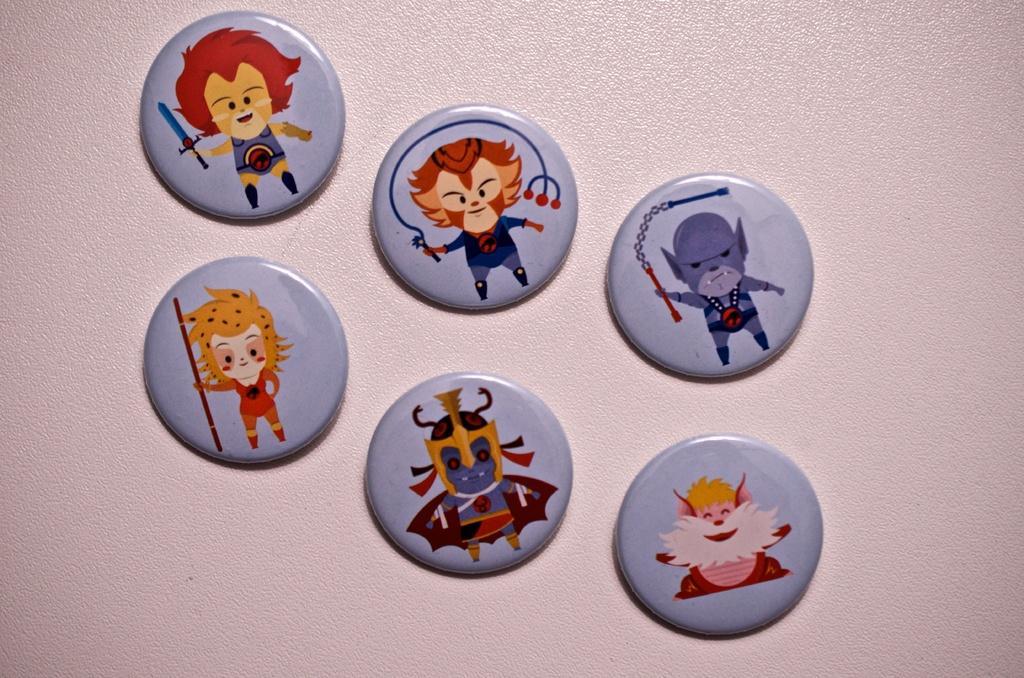How would you summarize this image in a sentence or two? In this image, we can see there are six gray color coins having different paintings, pasted on a surface. And the background is pink in color. 